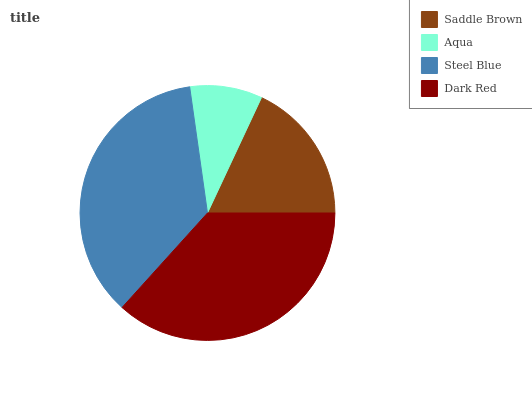Is Aqua the minimum?
Answer yes or no. Yes. Is Dark Red the maximum?
Answer yes or no. Yes. Is Steel Blue the minimum?
Answer yes or no. No. Is Steel Blue the maximum?
Answer yes or no. No. Is Steel Blue greater than Aqua?
Answer yes or no. Yes. Is Aqua less than Steel Blue?
Answer yes or no. Yes. Is Aqua greater than Steel Blue?
Answer yes or no. No. Is Steel Blue less than Aqua?
Answer yes or no. No. Is Steel Blue the high median?
Answer yes or no. Yes. Is Saddle Brown the low median?
Answer yes or no. Yes. Is Saddle Brown the high median?
Answer yes or no. No. Is Dark Red the low median?
Answer yes or no. No. 